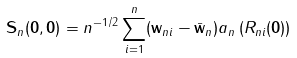Convert formula to latex. <formula><loc_0><loc_0><loc_500><loc_500>\mathbf S _ { n } ( \mathbf 0 , \mathbf 0 ) = n ^ { - 1 / 2 } \sum _ { i = 1 } ^ { n } ( { \mathbf w } _ { n i } - \bar { \mathbf w } _ { n } ) a _ { n } \left ( { R } _ { n i } ( \mathbf 0 ) \right )</formula> 